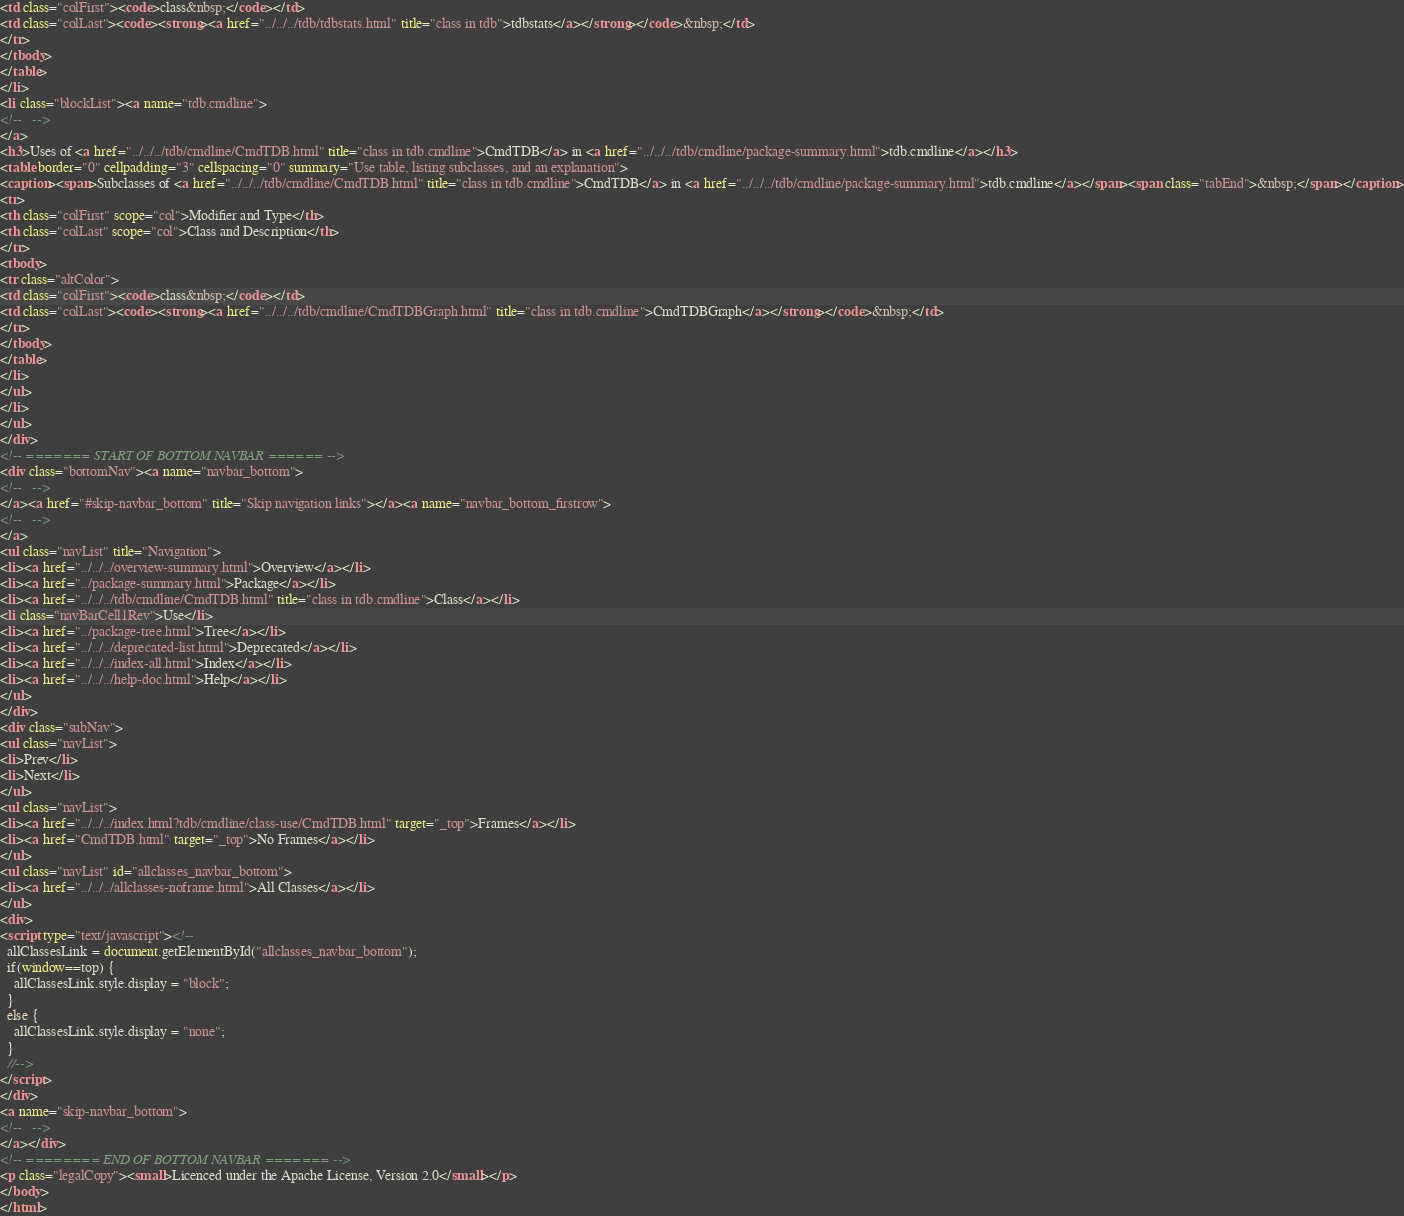Convert code to text. <code><loc_0><loc_0><loc_500><loc_500><_HTML_><td class="colFirst"><code>class&nbsp;</code></td>
<td class="colLast"><code><strong><a href="../../../tdb/tdbstats.html" title="class in tdb">tdbstats</a></strong></code>&nbsp;</td>
</tr>
</tbody>
</table>
</li>
<li class="blockList"><a name="tdb.cmdline">
<!--   -->
</a>
<h3>Uses of <a href="../../../tdb/cmdline/CmdTDB.html" title="class in tdb.cmdline">CmdTDB</a> in <a href="../../../tdb/cmdline/package-summary.html">tdb.cmdline</a></h3>
<table border="0" cellpadding="3" cellspacing="0" summary="Use table, listing subclasses, and an explanation">
<caption><span>Subclasses of <a href="../../../tdb/cmdline/CmdTDB.html" title="class in tdb.cmdline">CmdTDB</a> in <a href="../../../tdb/cmdline/package-summary.html">tdb.cmdline</a></span><span class="tabEnd">&nbsp;</span></caption>
<tr>
<th class="colFirst" scope="col">Modifier and Type</th>
<th class="colLast" scope="col">Class and Description</th>
</tr>
<tbody>
<tr class="altColor">
<td class="colFirst"><code>class&nbsp;</code></td>
<td class="colLast"><code><strong><a href="../../../tdb/cmdline/CmdTDBGraph.html" title="class in tdb.cmdline">CmdTDBGraph</a></strong></code>&nbsp;</td>
</tr>
</tbody>
</table>
</li>
</ul>
</li>
</ul>
</div>
<!-- ======= START OF BOTTOM NAVBAR ====== -->
<div class="bottomNav"><a name="navbar_bottom">
<!--   -->
</a><a href="#skip-navbar_bottom" title="Skip navigation links"></a><a name="navbar_bottom_firstrow">
<!--   -->
</a>
<ul class="navList" title="Navigation">
<li><a href="../../../overview-summary.html">Overview</a></li>
<li><a href="../package-summary.html">Package</a></li>
<li><a href="../../../tdb/cmdline/CmdTDB.html" title="class in tdb.cmdline">Class</a></li>
<li class="navBarCell1Rev">Use</li>
<li><a href="../package-tree.html">Tree</a></li>
<li><a href="../../../deprecated-list.html">Deprecated</a></li>
<li><a href="../../../index-all.html">Index</a></li>
<li><a href="../../../help-doc.html">Help</a></li>
</ul>
</div>
<div class="subNav">
<ul class="navList">
<li>Prev</li>
<li>Next</li>
</ul>
<ul class="navList">
<li><a href="../../../index.html?tdb/cmdline/class-use/CmdTDB.html" target="_top">Frames</a></li>
<li><a href="CmdTDB.html" target="_top">No Frames</a></li>
</ul>
<ul class="navList" id="allclasses_navbar_bottom">
<li><a href="../../../allclasses-noframe.html">All Classes</a></li>
</ul>
<div>
<script type="text/javascript"><!--
  allClassesLink = document.getElementById("allclasses_navbar_bottom");
  if(window==top) {
    allClassesLink.style.display = "block";
  }
  else {
    allClassesLink.style.display = "none";
  }
  //-->
</script>
</div>
<a name="skip-navbar_bottom">
<!--   -->
</a></div>
<!-- ======== END OF BOTTOM NAVBAR ======= -->
<p class="legalCopy"><small>Licenced under the Apache License, Version 2.0</small></p>
</body>
</html>
</code> 